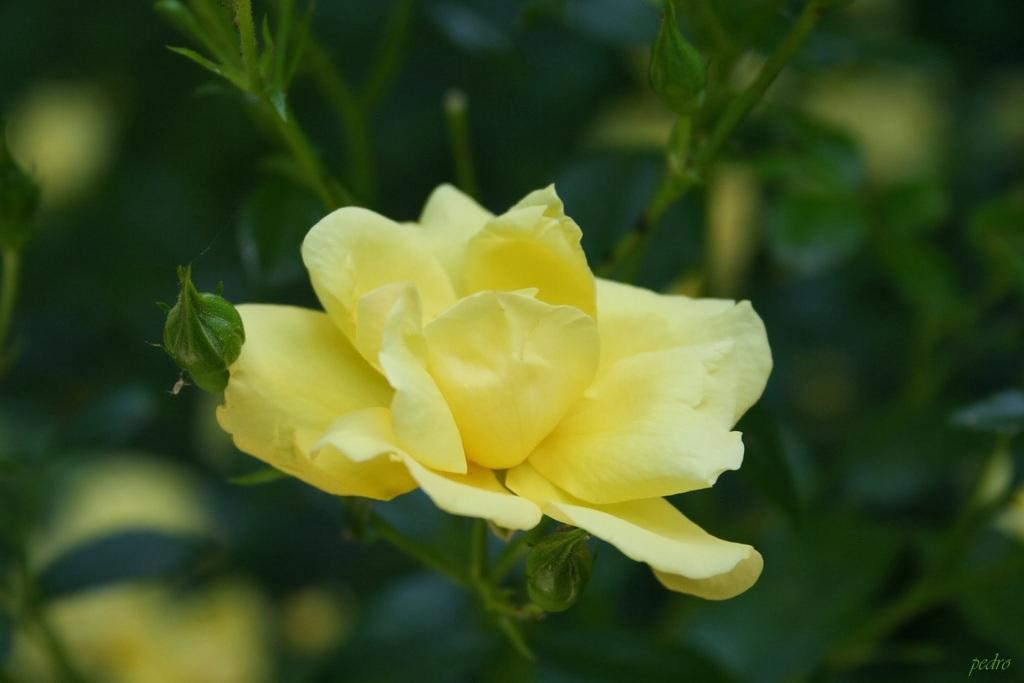What type of plant is in the image? There is a plant in the image, and it has a yellow flower. What can be seen in the background of the image? In the background, the image is blurred, and flowers and leaves are visible. How many pigs are visible in the image? There are no pigs present in the image. What type of ear is visible on the duck in the image? There is no duck present in the image. 